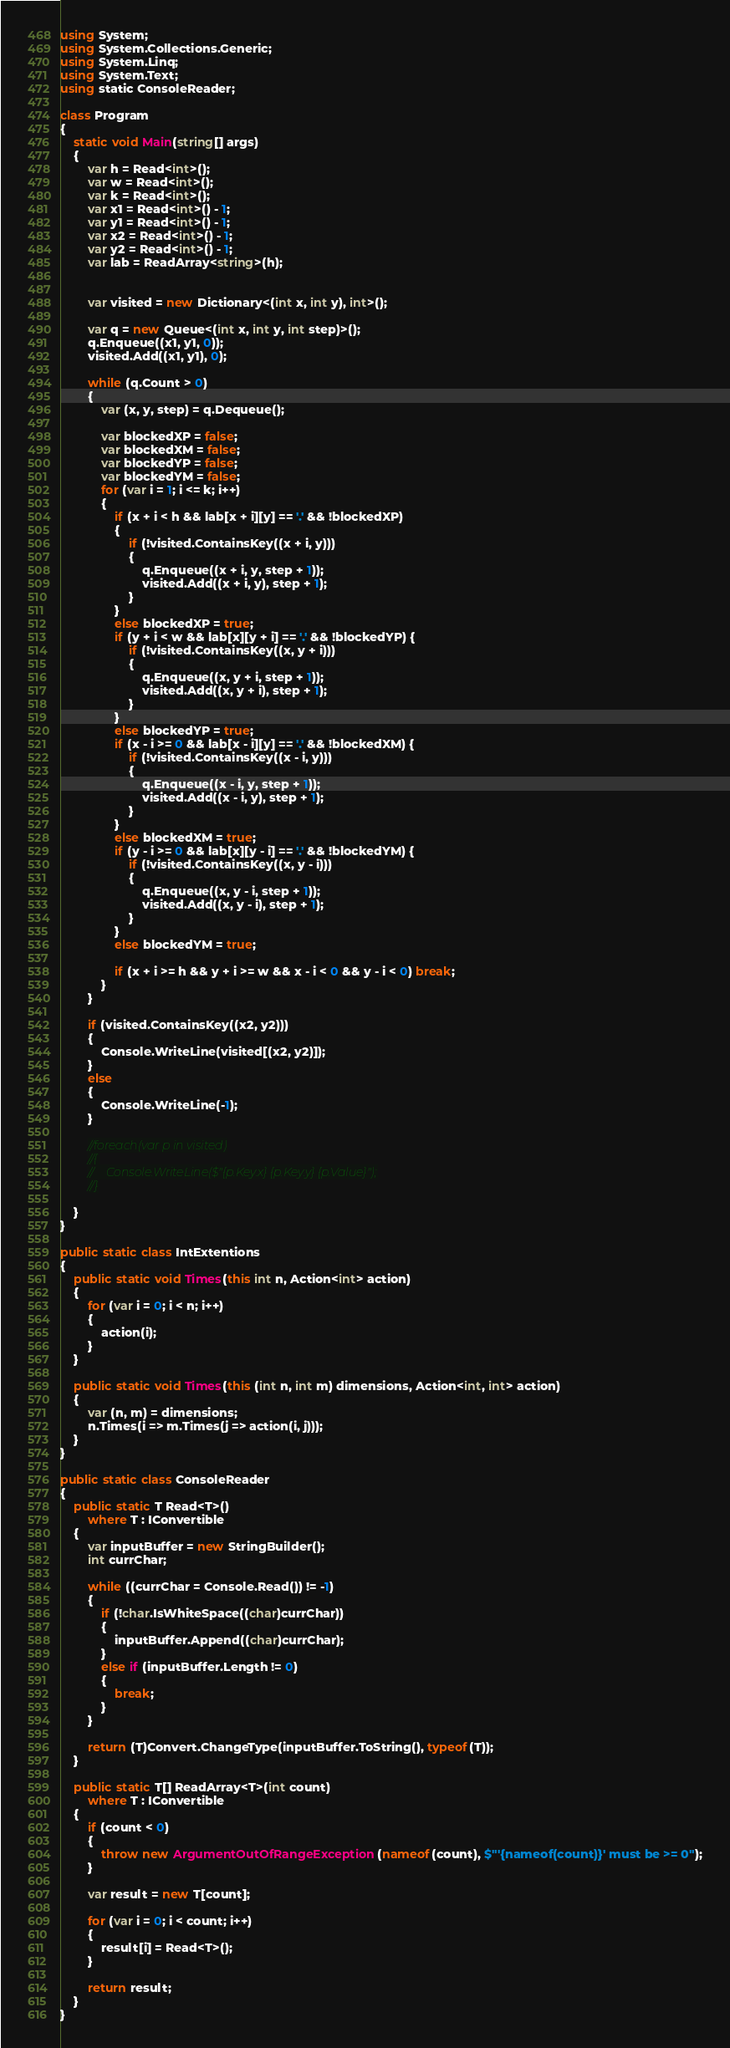<code> <loc_0><loc_0><loc_500><loc_500><_C#_>using System;
using System.Collections.Generic;
using System.Linq;
using System.Text;
using static ConsoleReader;

class Program
{
    static void Main(string[] args)
    {
        var h = Read<int>();
        var w = Read<int>();
        var k = Read<int>();
        var x1 = Read<int>() - 1;
        var y1 = Read<int>() - 1;
        var x2 = Read<int>() - 1;
        var y2 = Read<int>() - 1;
        var lab = ReadArray<string>(h);


        var visited = new Dictionary<(int x, int y), int>();

        var q = new Queue<(int x, int y, int step)>();
        q.Enqueue((x1, y1, 0));
        visited.Add((x1, y1), 0);

        while (q.Count > 0)
        {
            var (x, y, step) = q.Dequeue();

            var blockedXP = false;
            var blockedXM = false;
            var blockedYP = false;
            var blockedYM = false;
            for (var i = 1; i <= k; i++)
            {
                if (x + i < h && lab[x + i][y] == '.' && !blockedXP)
                {
                    if (!visited.ContainsKey((x + i, y)))
                    {
                        q.Enqueue((x + i, y, step + 1));
                        visited.Add((x + i, y), step + 1);
                    }
                }
                else blockedXP = true;
                if (y + i < w && lab[x][y + i] == '.' && !blockedYP) {
                    if (!visited.ContainsKey((x, y + i)))
                    {
                        q.Enqueue((x, y + i, step + 1));
                        visited.Add((x, y + i), step + 1);
                    }
                }
                else blockedYP = true;
                if (x - i >= 0 && lab[x - i][y] == '.' && !blockedXM) {
                    if (!visited.ContainsKey((x - i, y)))
                    {
                        q.Enqueue((x - i, y, step + 1));
                        visited.Add((x - i, y), step + 1);
                    }
                }
                else blockedXM = true;
                if (y - i >= 0 && lab[x][y - i] == '.' && !blockedYM) {
                    if (!visited.ContainsKey((x, y - i)))
                    {
                        q.Enqueue((x, y - i, step + 1));
                        visited.Add((x, y - i), step + 1);
                    }
                }
                else blockedYM = true;

                if (x + i >= h && y + i >= w && x - i < 0 && y - i < 0) break;
            }
        }

        if (visited.ContainsKey((x2, y2)))
        {
            Console.WriteLine(visited[(x2, y2)]);
        }
        else
        {
            Console.WriteLine(-1);
        }

        //foreach(var p in visited)
        //{
        //    Console.WriteLine($"{p.Key.x} {p.Key.y} {p.Value}");
        //}

    }
}

public static class IntExtentions
{
    public static void Times(this int n, Action<int> action)
    {
        for (var i = 0; i < n; i++)
        {
            action(i);
        }
    }

    public static void Times(this (int n, int m) dimensions, Action<int, int> action)
    {
        var (n, m) = dimensions;
        n.Times(i => m.Times(j => action(i, j)));
    }
}

public static class ConsoleReader
{
    public static T Read<T>()
        where T : IConvertible
    {
        var inputBuffer = new StringBuilder();
        int currChar;

        while ((currChar = Console.Read()) != -1)
        {
            if (!char.IsWhiteSpace((char)currChar))
            {
                inputBuffer.Append((char)currChar);
            }
            else if (inputBuffer.Length != 0)
            {
                break;
            }
        }

        return (T)Convert.ChangeType(inputBuffer.ToString(), typeof(T));
    }

    public static T[] ReadArray<T>(int count)
        where T : IConvertible
    {
        if (count < 0)
        {
            throw new ArgumentOutOfRangeException(nameof(count), $"'{nameof(count)}' must be >= 0");
        }

        var result = new T[count];

        for (var i = 0; i < count; i++)
        {
            result[i] = Read<T>();
        }

        return result;
    }
}</code> 